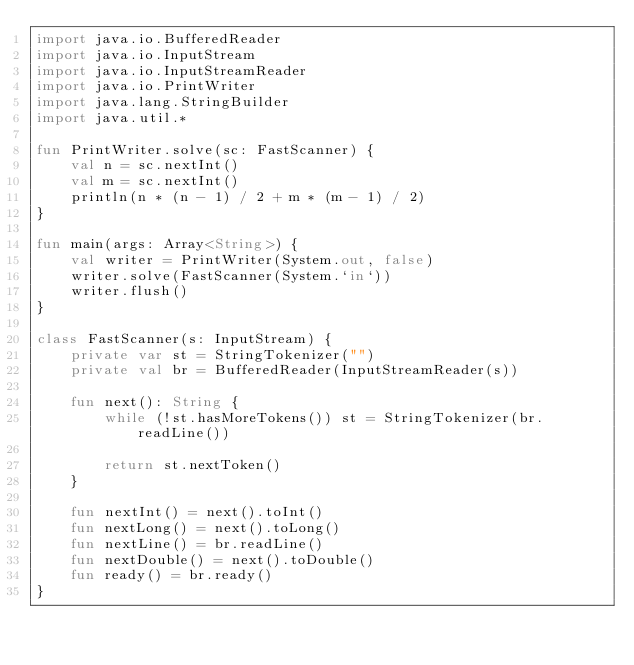<code> <loc_0><loc_0><loc_500><loc_500><_Kotlin_>import java.io.BufferedReader
import java.io.InputStream
import java.io.InputStreamReader
import java.io.PrintWriter
import java.lang.StringBuilder
import java.util.*

fun PrintWriter.solve(sc: FastScanner) {
    val n = sc.nextInt()
    val m = sc.nextInt()
    println(n * (n - 1) / 2 + m * (m - 1) / 2)
}

fun main(args: Array<String>) {
    val writer = PrintWriter(System.out, false)
    writer.solve(FastScanner(System.`in`))
    writer.flush()
}

class FastScanner(s: InputStream) {
    private var st = StringTokenizer("")
    private val br = BufferedReader(InputStreamReader(s))

    fun next(): String {
        while (!st.hasMoreTokens()) st = StringTokenizer(br.readLine())

        return st.nextToken()
    }

    fun nextInt() = next().toInt()
    fun nextLong() = next().toLong()
    fun nextLine() = br.readLine()
    fun nextDouble() = next().toDouble()
    fun ready() = br.ready()
}
</code> 